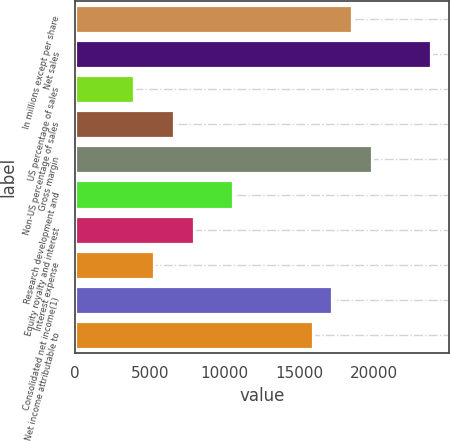Convert chart to OTSL. <chart><loc_0><loc_0><loc_500><loc_500><bar_chart><fcel>In millions except per share<fcel>Net sales<fcel>US percentage of sales<fcel>Non-US percentage of sales<fcel>Gross margin<fcel>Research development and<fcel>Equity royalty and interest<fcel>Interest expense<fcel>Consolidated net income(1)<fcel>Net income attributable to<nl><fcel>18516<fcel>23806.1<fcel>3968.41<fcel>6613.43<fcel>19838.5<fcel>10581<fcel>7935.94<fcel>5290.92<fcel>17193.5<fcel>15871<nl></chart> 